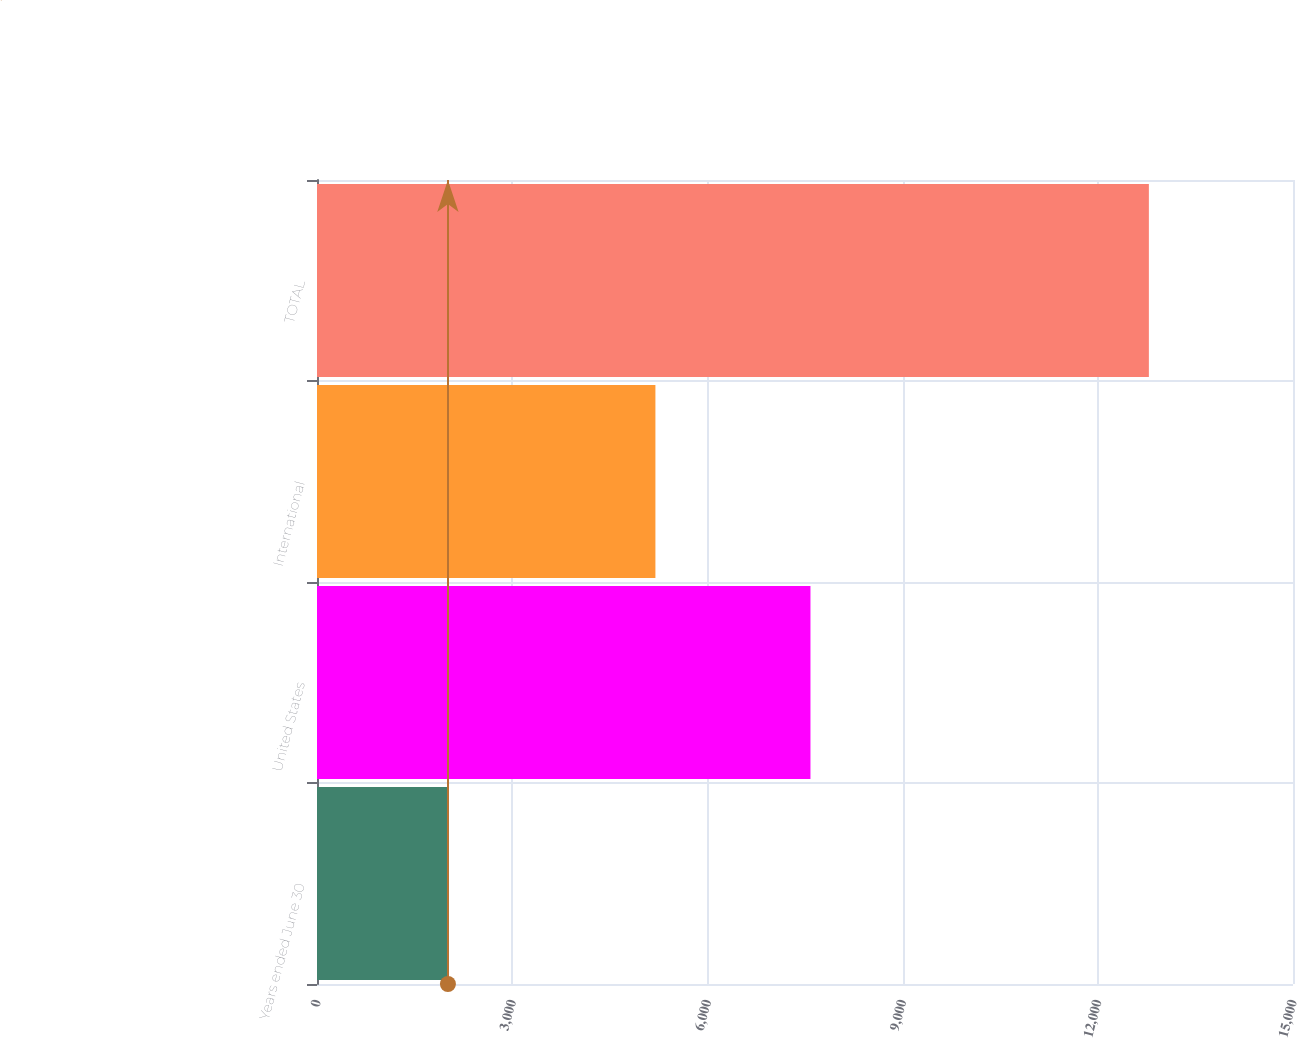<chart> <loc_0><loc_0><loc_500><loc_500><bar_chart><fcel>Years ended June 30<fcel>United States<fcel>International<fcel>TOTAL<nl><fcel>2012<fcel>7584<fcel>5201<fcel>12785<nl></chart> 